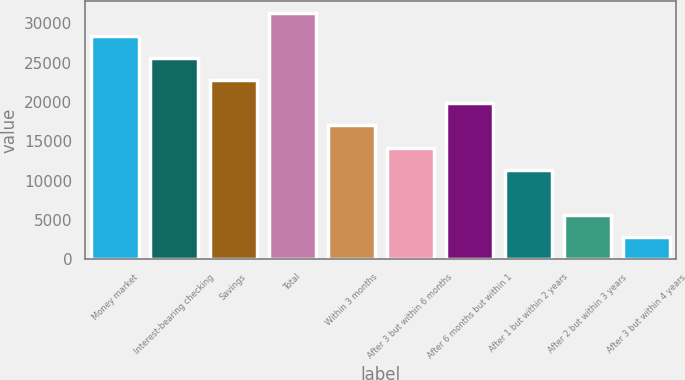Convert chart to OTSL. <chart><loc_0><loc_0><loc_500><loc_500><bar_chart><fcel>Money market<fcel>Interest-bearing checking<fcel>Savings<fcel>Total<fcel>Within 3 months<fcel>After 3 but within 6 months<fcel>After 6 months but within 1<fcel>After 1 but within 2 years<fcel>After 2 but within 3 years<fcel>After 3 but within 4 years<nl><fcel>28417.4<fcel>25575.7<fcel>22734<fcel>31259.1<fcel>17050.6<fcel>14208.9<fcel>19892.3<fcel>11367.1<fcel>5683.72<fcel>2842.01<nl></chart> 